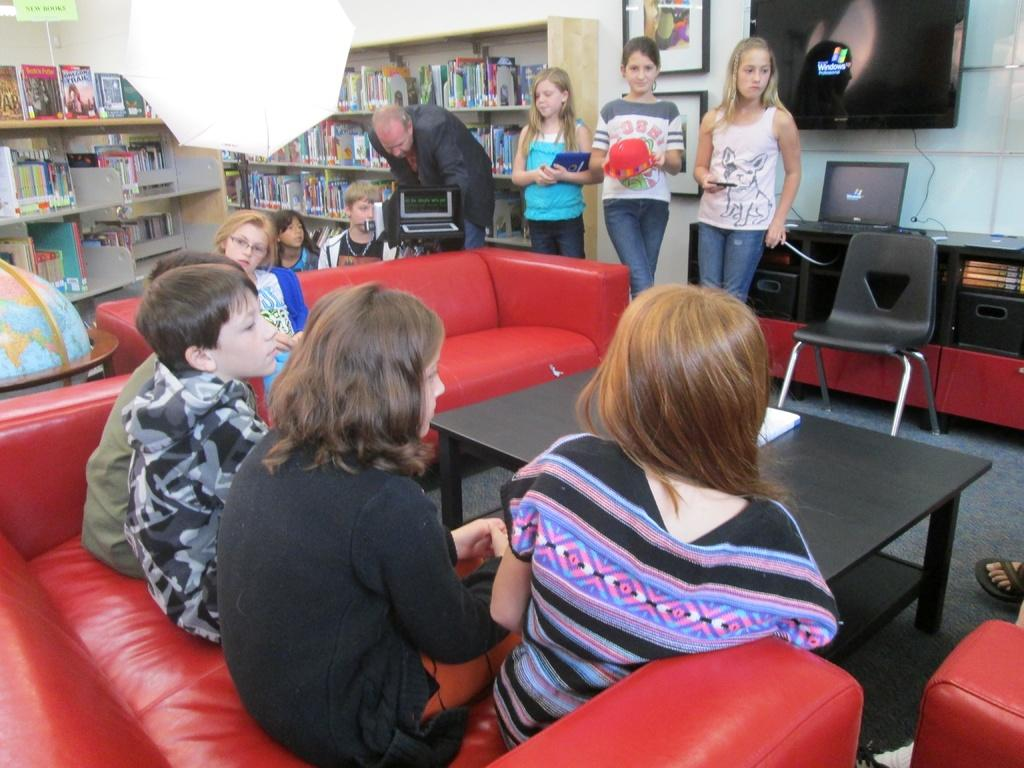Provide a one-sentence caption for the provided image. Some teenagers stand near a monitor with the Windows brand on a black screen. 